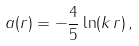Convert formula to latex. <formula><loc_0><loc_0><loc_500><loc_500>a ( r ) = - \frac { 4 } { 5 } \ln ( k \, r ) \, ,</formula> 